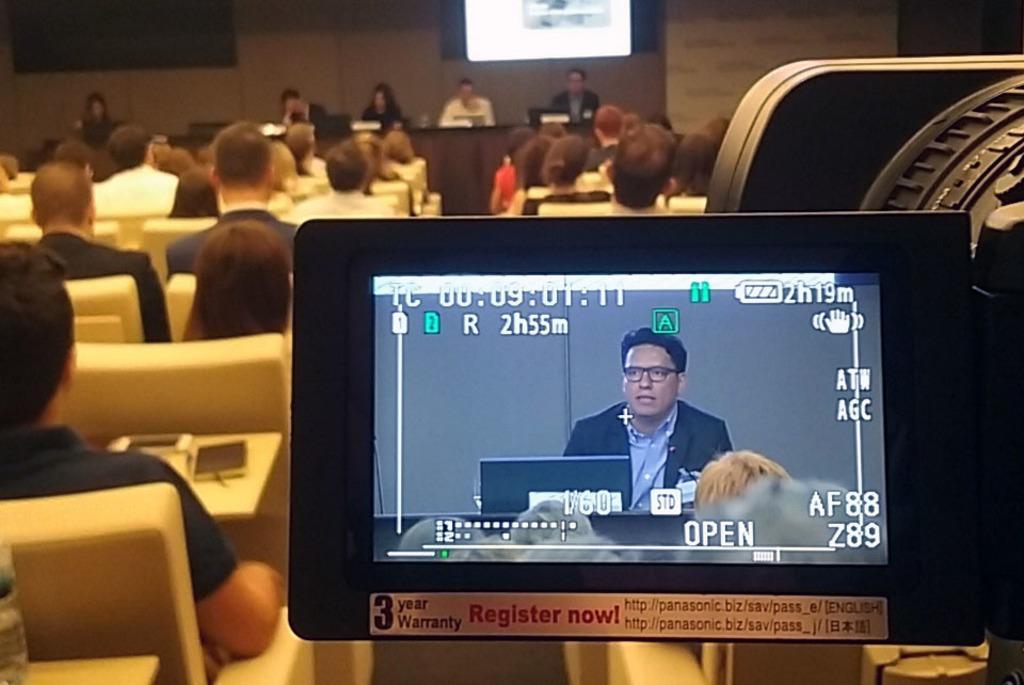How would you summarize this image in a sentence or two? In this image we can see a person on the display screen, persons sitting on the chairs and walls. 